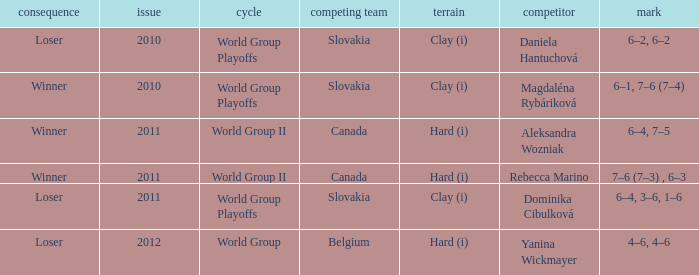What was the score when the opposing team was from Belgium? 4–6, 4–6. 